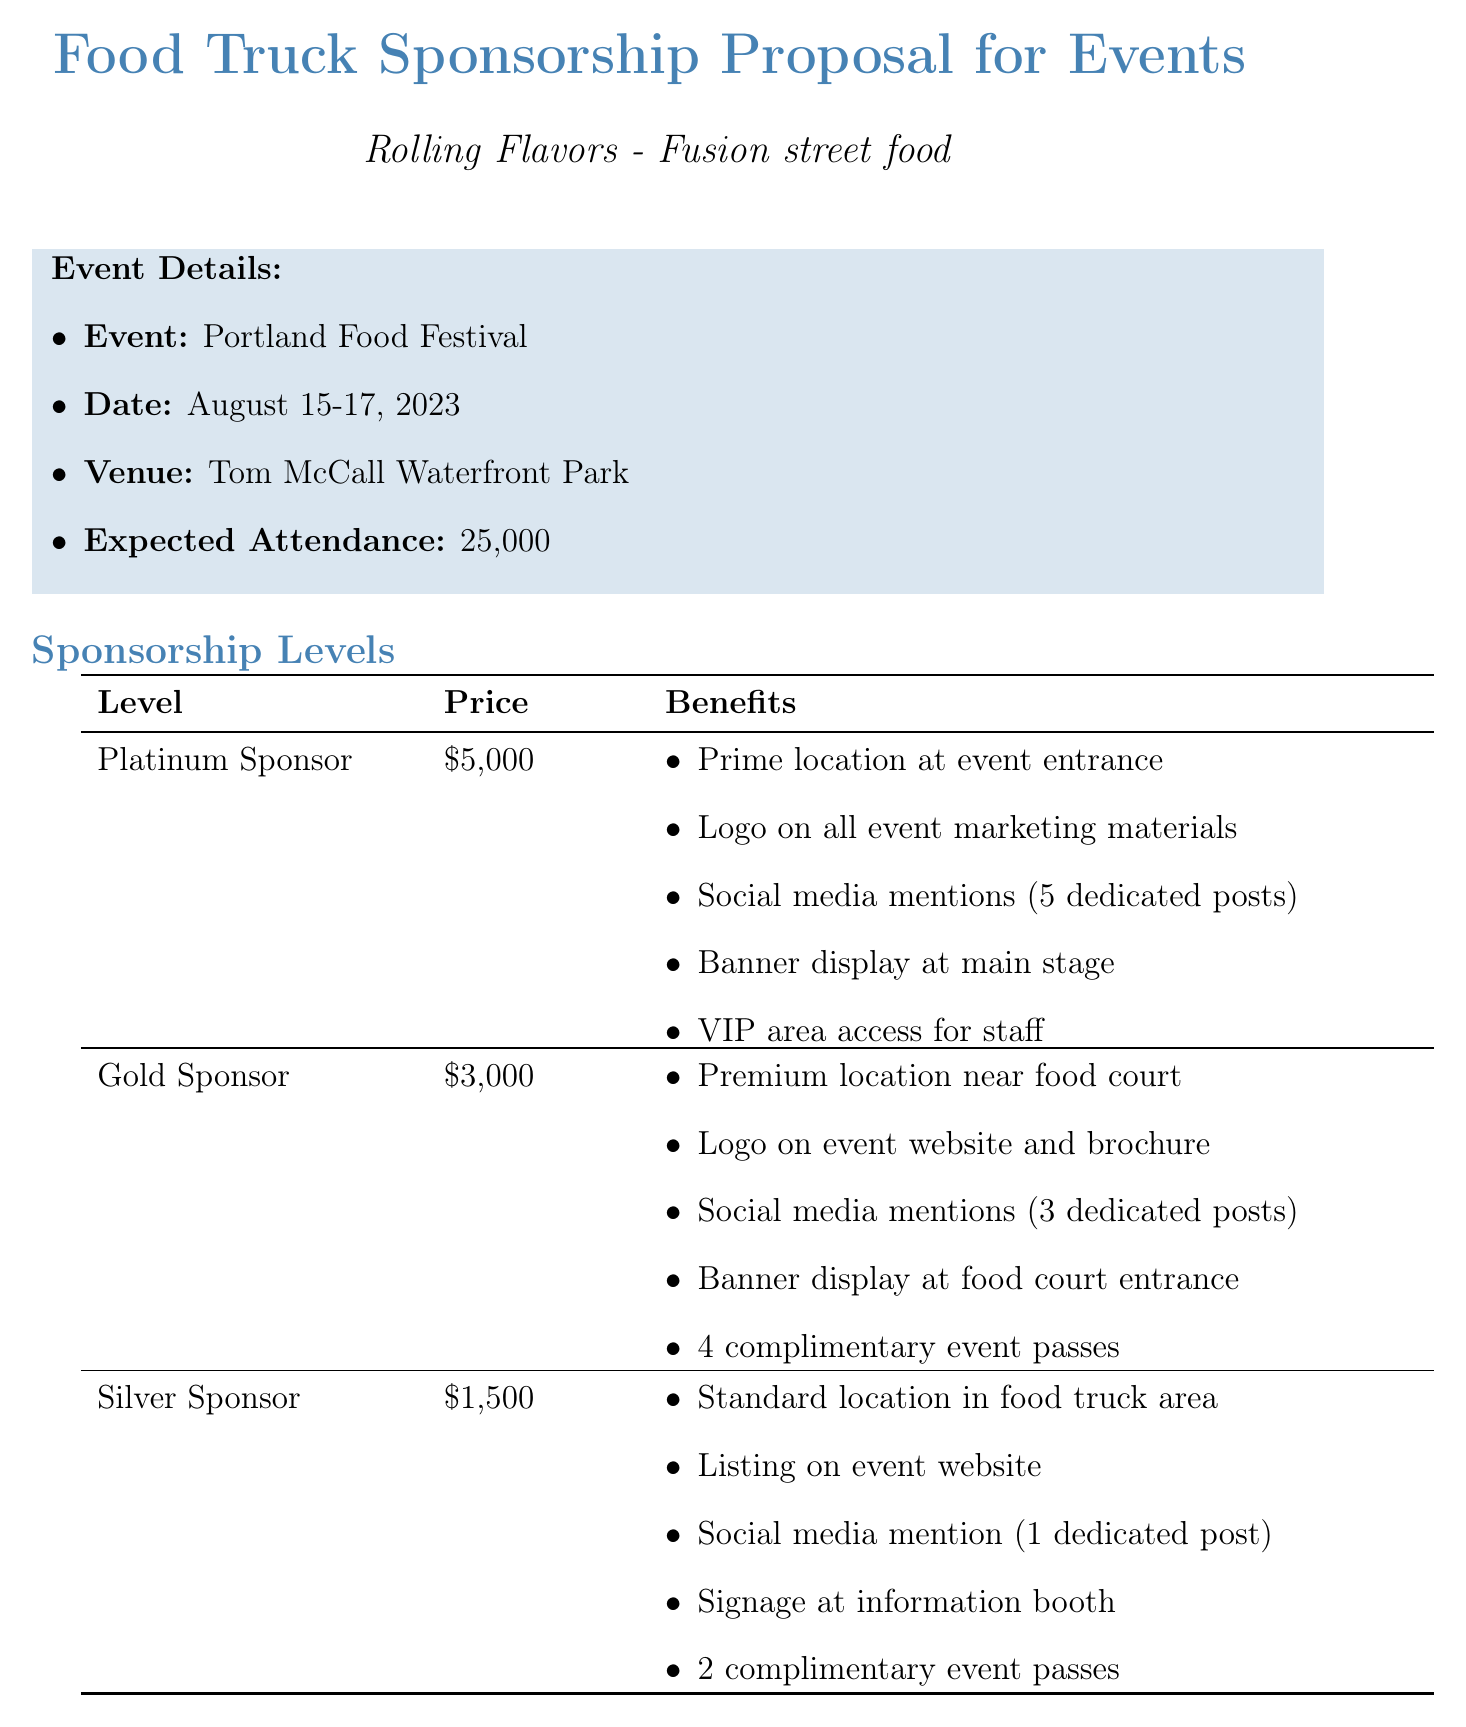What is the food truck's name? The food truck's name is stated in the document under business information.
Answer: Rolling Flavors Who is the owner of the food truck? The owner's name is mentioned in the business information section.
Answer: Sarah Thompson What is the price of the Platinum Sponsorship? This information can be found in the sponsorship levels table.
Answer: $5000 How many expected attendees are there at the event? The expected attendance figure is provided in the event details section.
Answer: 25,000 What is the cancellation policy stated in the document? The cancellation policy is outlined in the additional information section.
Answer: 50% refund if cancelled 30 days before event, no refund after that Which marketing opportunity involves participation in cooking? This is specified under marketing opportunities in the document.
Answer: Participation in cooking demonstrations What was the result for Taco Fiesta after becoming a Gold Sponsor? The outcome for Taco Fiesta is stated in the success stories section.
Answer: Increased social media followers by 50% and secured 3 corporate event contracts What are the payment options available for sponsorship? The payment options are listed in the document and entail various methods.
Answer: Full payment upfront (5% discount), 50% deposit, remainder due 1 week before event, Monthly installment plan (for Platinum sponsors only) What is the event venue for the Portland Food Festival? The venue for the event is specified in the event details.
Answer: Tom McCall Waterfront Park 